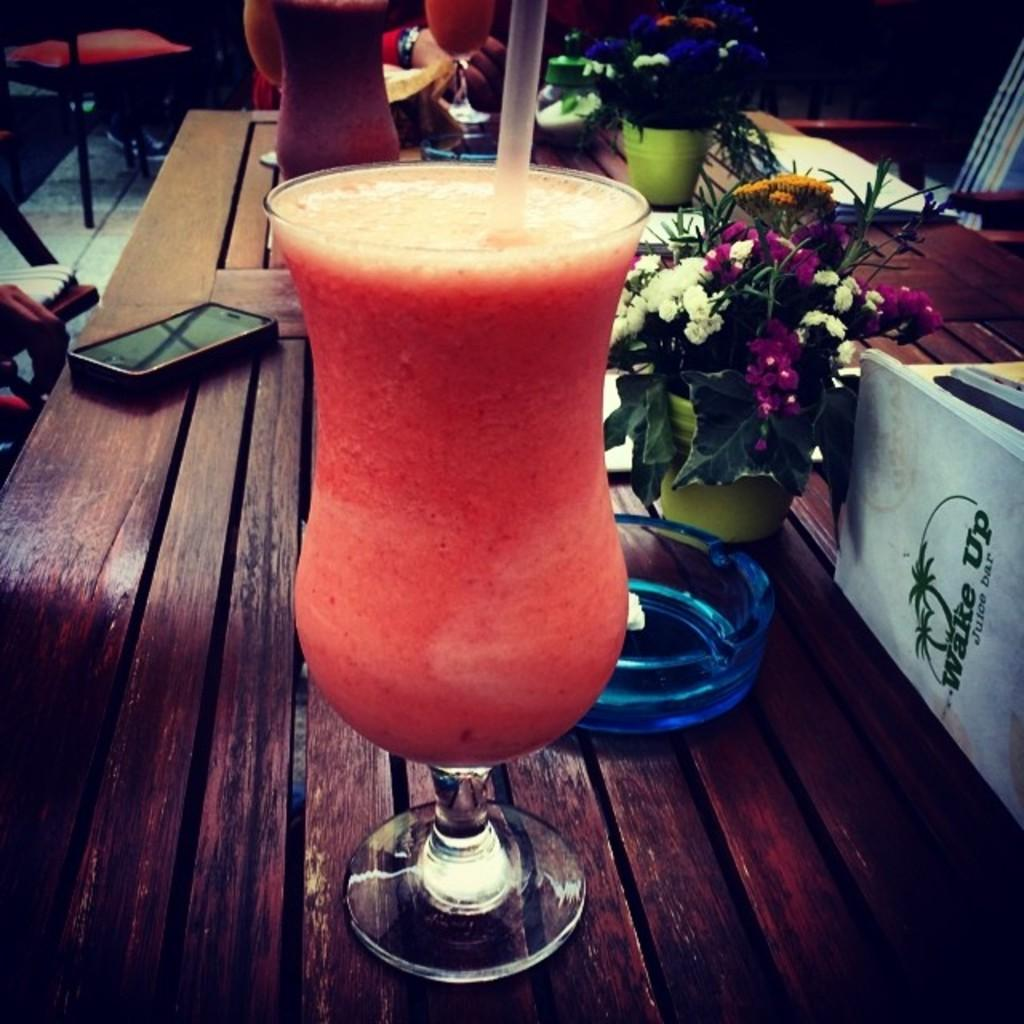What type of furniture is present in the image? There is a chair in the image. Who or what is present in the image? There is a person in the image. What can be seen on the table in the image? There are two glasses of juice with straws, a mobile, and a flower vase on the table. What type of jeans is the laborer wearing in the image? There is no laborer or jeans present in the image. How many oranges are visible in the image? There are no oranges present in the image. 